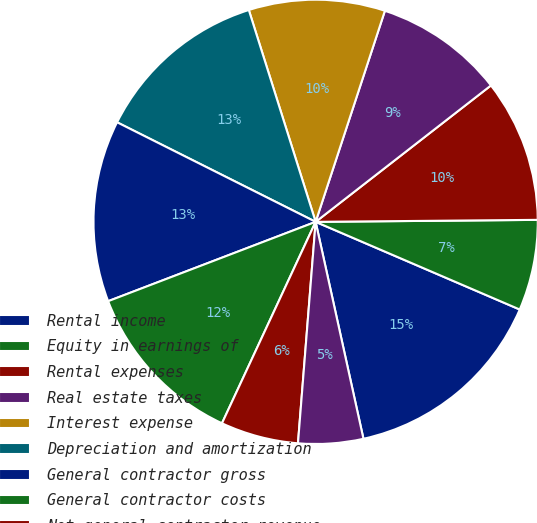Convert chart to OTSL. <chart><loc_0><loc_0><loc_500><loc_500><pie_chart><fcel>Rental income<fcel>Equity in earnings of<fcel>Rental expenses<fcel>Real estate taxes<fcel>Interest expense<fcel>Depreciation and amortization<fcel>General contractor gross<fcel>General contractor costs<fcel>Net general contractor revenue<fcel>Property management<nl><fcel>15.09%<fcel>6.6%<fcel>10.38%<fcel>9.43%<fcel>9.91%<fcel>12.74%<fcel>13.21%<fcel>12.26%<fcel>5.66%<fcel>4.72%<nl></chart> 